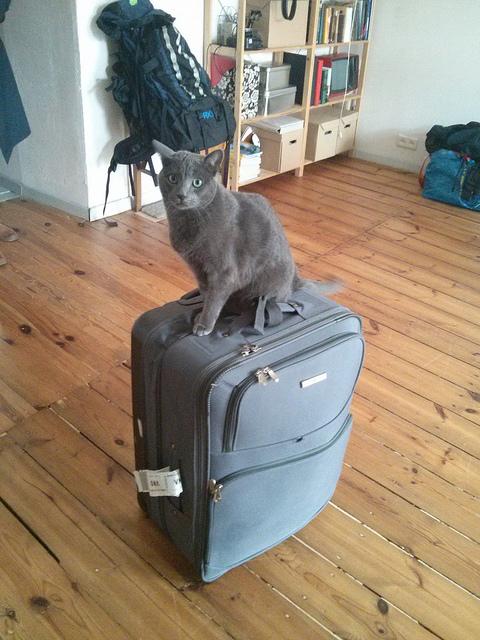What is under the cat?
Write a very short answer. Suitcase. Does the cat look happy?
Answer briefly. No. What type of wood was used for the flooring?
Write a very short answer. Oak. 